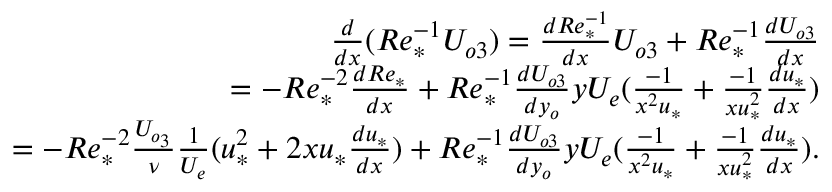<formula> <loc_0><loc_0><loc_500><loc_500>\begin{array} { r } { \frac { d } { d x } ( R e _ { * } ^ { - 1 } U _ { o 3 } ) = \frac { d R e _ { * } ^ { - 1 } } { d x } U _ { o 3 } + R e _ { * } ^ { - 1 } \frac { d U _ { o 3 } } { d x } } \\ { = - R e _ { * } ^ { - 2 } \frac { d R e _ { * } } { d x } + R e _ { * } ^ { - 1 } \frac { d U _ { o 3 } } { d y _ { o } } y U _ { e } ( \frac { - 1 } { x ^ { 2 } u _ { * } } + \frac { - 1 } { x u _ { * } ^ { 2 } } \frac { d u _ { * } } { d x } ) } \\ { = - R e _ { * } ^ { - 2 } \frac { U _ { o _ { 3 } } } { \nu } \frac { 1 } { U _ { e } } ( u _ { * } ^ { 2 } + 2 x u _ { * } \frac { d u _ { * } } { d x } ) + R e _ { * } ^ { - 1 } \frac { d U _ { o 3 } } { d y _ { o } } y U _ { e } ( \frac { - 1 } { x ^ { 2 } u _ { * } } + \frac { - 1 } { x u _ { * } ^ { 2 } } \frac { d u _ { * } } { d x } ) . } \end{array}</formula> 